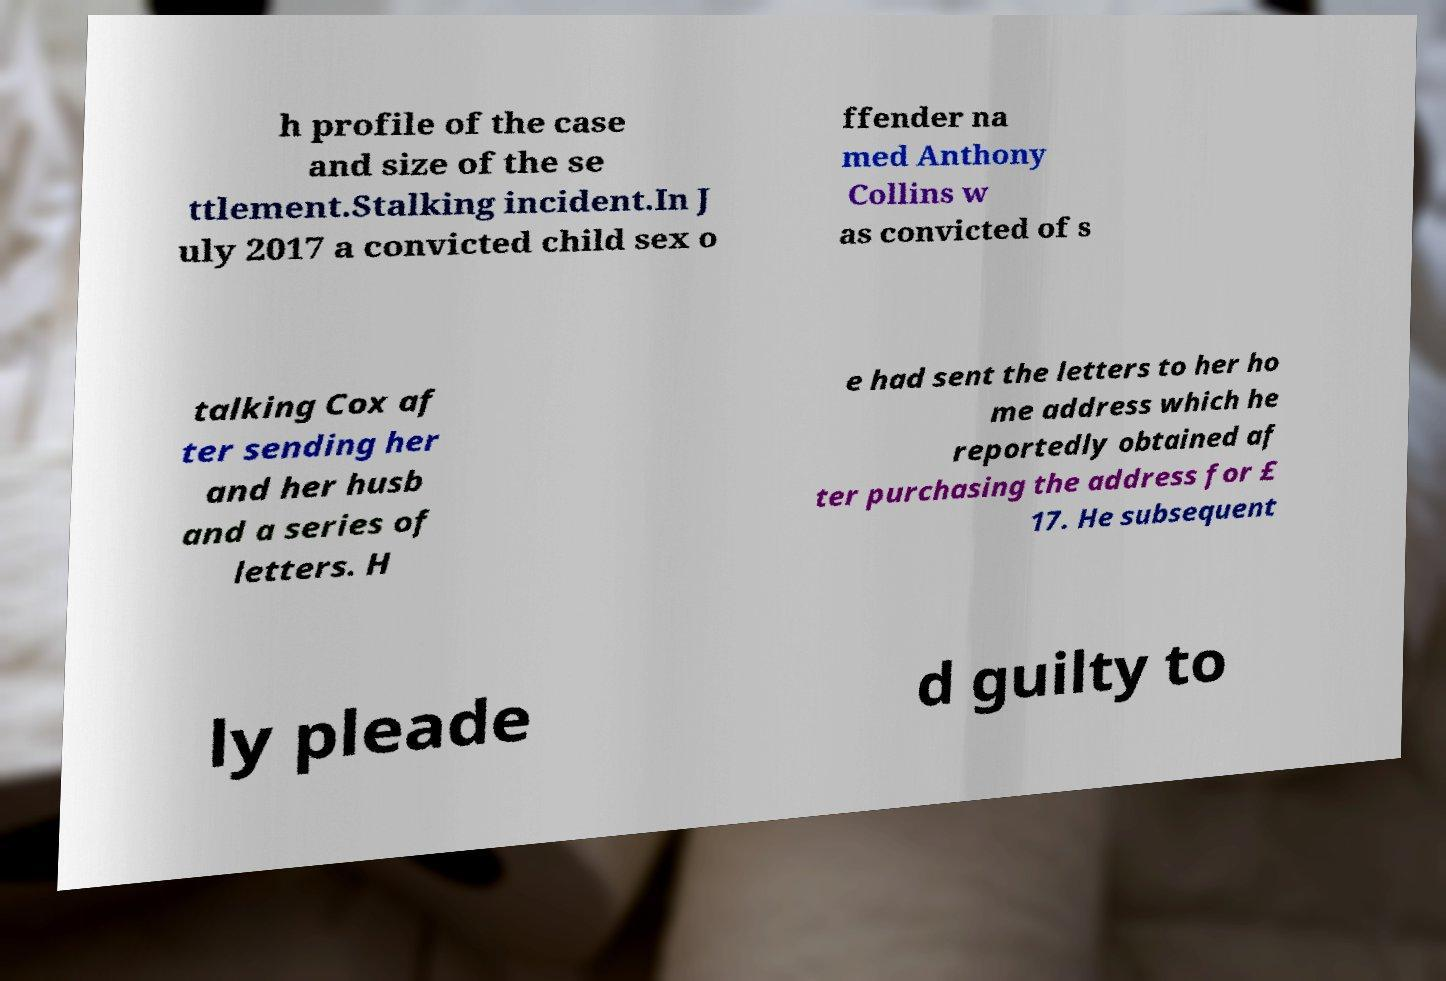Can you read and provide the text displayed in the image?This photo seems to have some interesting text. Can you extract and type it out for me? h profile of the case and size of the se ttlement.Stalking incident.In J uly 2017 a convicted child sex o ffender na med Anthony Collins w as convicted of s talking Cox af ter sending her and her husb and a series of letters. H e had sent the letters to her ho me address which he reportedly obtained af ter purchasing the address for £ 17. He subsequent ly pleade d guilty to 